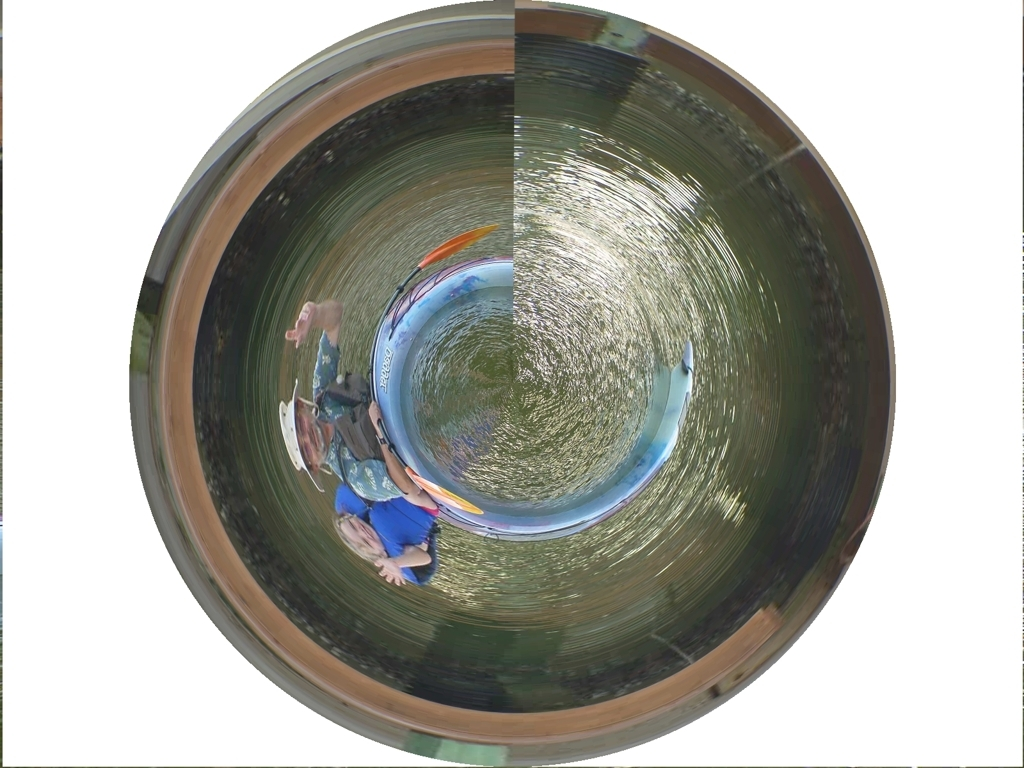What might be happening in this scene? The image presents a distorted view of a group of individuals, possibly engaged in a leisure activity outdoors. Due to the 'tiny planet' effect, determining their exact activity is challenging. However, they seem to be congregated casually, suggesting they might be socializing or preparing to start an activity together. Is this image suitable for any particular use? This kind of image, while not conventional, could be used artistically to represent a unique perspective or concept. It might be well-suited for album covers, creative marketing materials, or social media posts that aim to draw attention through visual novelty. 